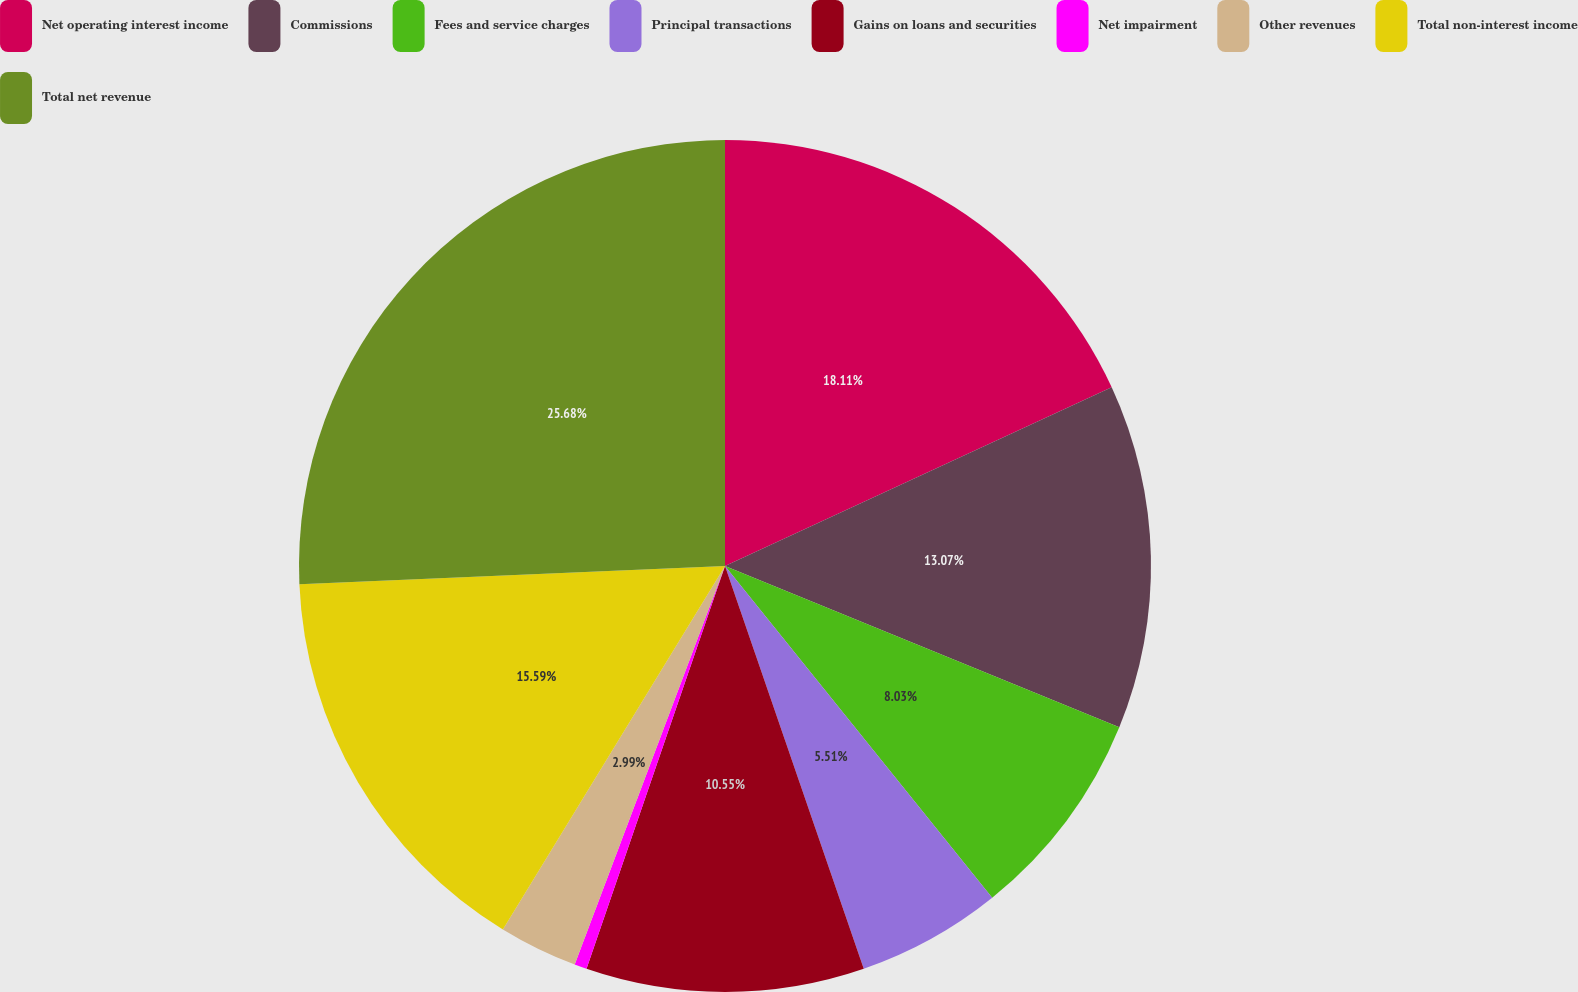Convert chart. <chart><loc_0><loc_0><loc_500><loc_500><pie_chart><fcel>Net operating interest income<fcel>Commissions<fcel>Fees and service charges<fcel>Principal transactions<fcel>Gains on loans and securities<fcel>Net impairment<fcel>Other revenues<fcel>Total non-interest income<fcel>Total net revenue<nl><fcel>18.11%<fcel>13.07%<fcel>8.03%<fcel>5.51%<fcel>10.55%<fcel>0.47%<fcel>2.99%<fcel>15.59%<fcel>25.68%<nl></chart> 